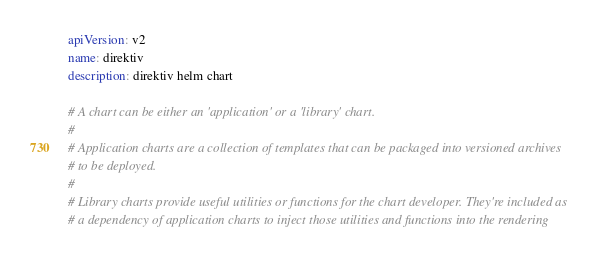<code> <loc_0><loc_0><loc_500><loc_500><_YAML_>apiVersion: v2
name: direktiv
description: direktiv helm chart

# A chart can be either an 'application' or a 'library' chart.
#
# Application charts are a collection of templates that can be packaged into versioned archives
# to be deployed.
#
# Library charts provide useful utilities or functions for the chart developer. They're included as
# a dependency of application charts to inject those utilities and functions into the rendering</code> 